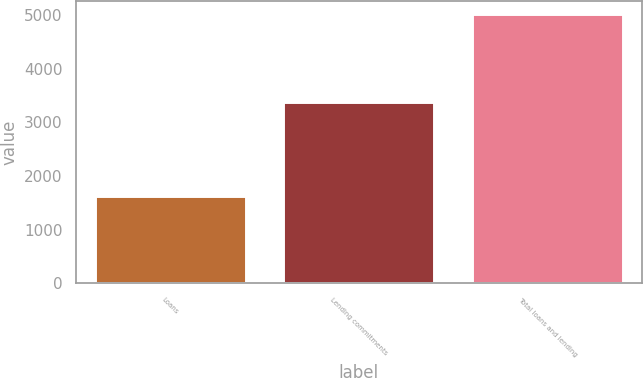<chart> <loc_0><loc_0><loc_500><loc_500><bar_chart><fcel>Loans<fcel>Lending commitments<fcel>Total loans and lending<nl><fcel>1622<fcel>3391<fcel>5013<nl></chart> 